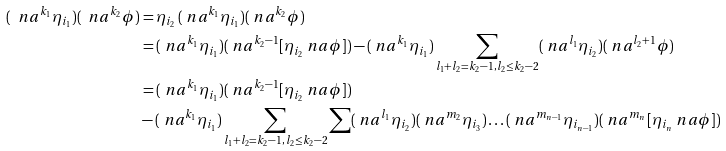Convert formula to latex. <formula><loc_0><loc_0><loc_500><loc_500>( \ n a ^ { k _ { 1 } } \eta _ { i _ { 1 } } ) ( \ n a ^ { k _ { 2 } } \phi ) & = \eta _ { i _ { 2 } } \, ( \ n a ^ { k _ { 1 } } \eta _ { i _ { 1 } } ) ( \ n a ^ { k _ { 2 } } \phi ) \\ & = ( \ n a ^ { k _ { 1 } } \eta _ { i _ { 1 } } ) ( \ n a ^ { k _ { 2 } - 1 } [ \eta _ { i _ { 2 } } \ n a \phi ] ) - ( \ n a ^ { k _ { 1 } } \eta _ { i _ { 1 } } ) \sum _ { l _ { 1 } + l _ { 2 } = k _ { 2 } - 1 , \, l _ { 2 } \leq k _ { 2 } - 2 } ( \ n a ^ { l _ { 1 } } \eta _ { i _ { 2 } } ) ( \ n a ^ { l _ { 2 } + 1 } \phi ) \\ & = ( \ n a ^ { k _ { 1 } } \eta _ { i _ { 1 } } ) ( \ n a ^ { k _ { 2 } - 1 } [ \eta _ { i _ { 2 } } \ n a \phi ] ) \\ & - ( \ n a ^ { k _ { 1 } } \eta _ { i _ { 1 } } ) \sum _ { l _ { 1 } + l _ { 2 } = k _ { 2 } - 1 , \, l _ { 2 } \leq k _ { 2 } - 2 } \sum ( \ n a ^ { l _ { 1 } } \eta _ { i _ { 2 } } ) ( \ n a ^ { m _ { 2 } } \eta _ { i _ { 3 } } ) \dots ( \ n a ^ { m _ { n - 1 } } \eta _ { i _ { n - 1 } } ) ( \ n a ^ { m _ { n } } [ \eta _ { i _ { n } } \ n a \phi ] )</formula> 